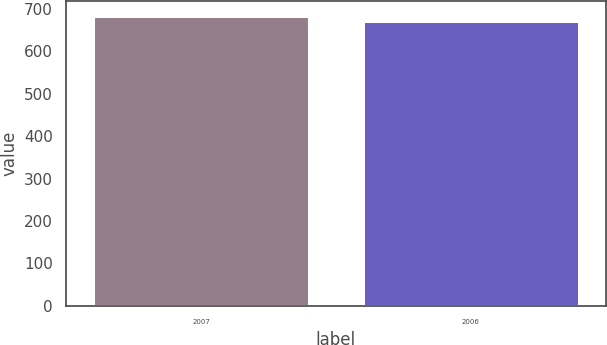<chart> <loc_0><loc_0><loc_500><loc_500><bar_chart><fcel>2007<fcel>2006<nl><fcel>684.3<fcel>672.6<nl></chart> 